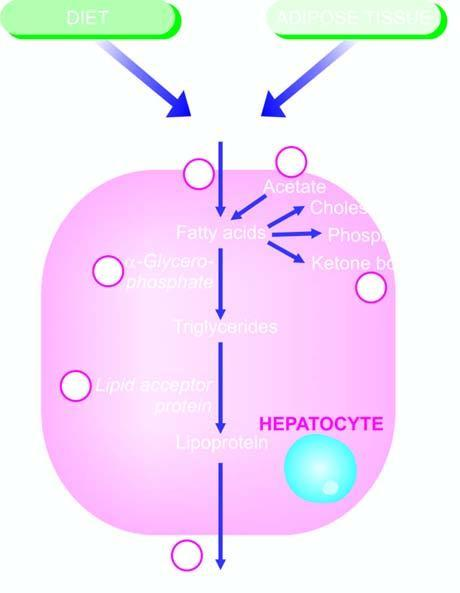can defects in any of the six number steps produce fatty liver by different etiologic agents?
Answer the question using a single word or phrase. Yes 